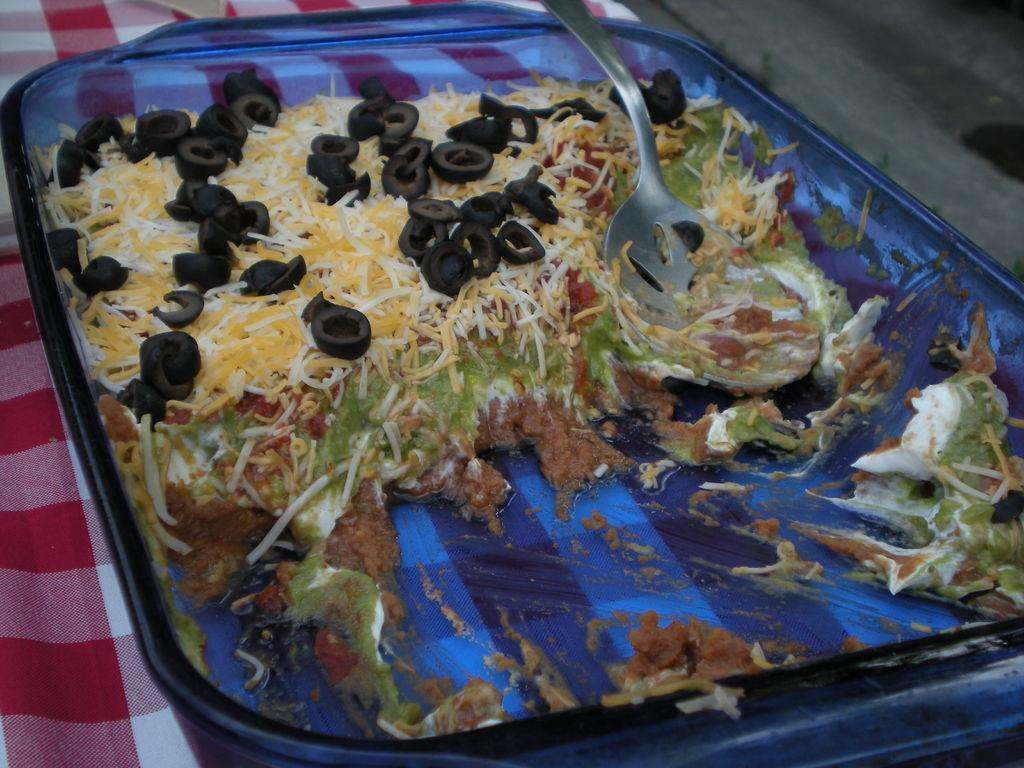What is on the table in the image? There is a plate on the table. What is on the plate? The plate contains food. What utensil is in the plate? There is a spoon in the plate. What type of property is visible in the background of the image? There is no property visible in the background of the image. Can you see a garden in the image? There is no garden present in the image. What shoe is the person wearing in the image? There is no person or shoe visible in the image. 